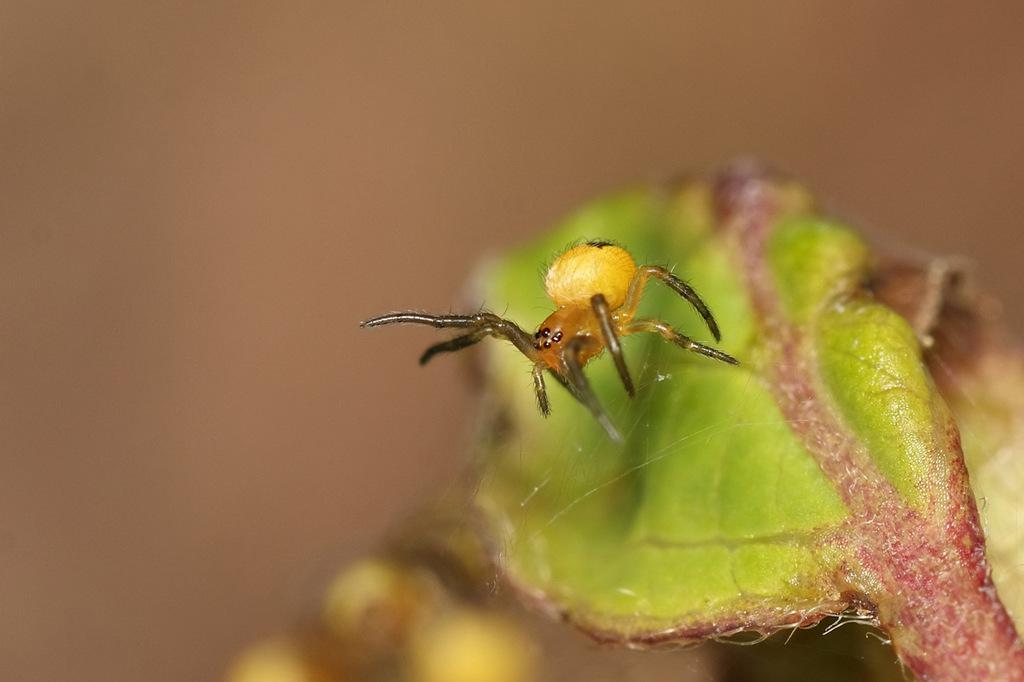What is present on the leaf in the image? There is an insect on a leaf in the image. What can be seen in the background of the image? There is a wall visible in the background of the image. What shape are the bells that the insect is ringing in the image? There are no bells present in the image, so it is not possible to determine their shape. 